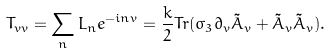<formula> <loc_0><loc_0><loc_500><loc_500>T _ { v v } = \sum _ { n } L _ { n } e ^ { - i n v } = \frac { k } { 2 } T r ( \sigma _ { 3 } \partial _ { v } \tilde { A } _ { v } + \tilde { A } _ { v } \tilde { A } _ { v } ) .</formula> 